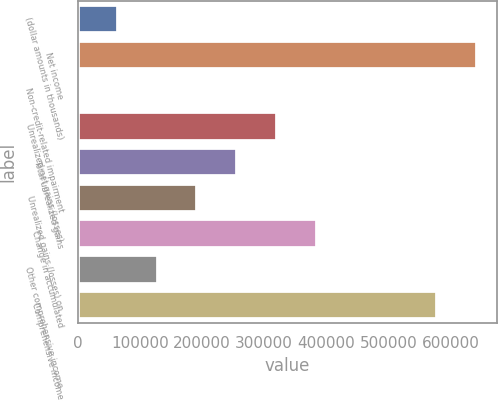Convert chart to OTSL. <chart><loc_0><loc_0><loc_500><loc_500><bar_chart><fcel>(dollar amounts in thousands)<fcel>Net income<fcel>Non-credit-related impairment<fcel>Unrealized net gains (losses)<fcel>Total unrealized gains<fcel>Unrealized gains (losses) on<fcel>Change in accumulated<fcel>Other comprehensive income<fcel>Comprehensive income<nl><fcel>64265.9<fcel>642203<fcel>153<fcel>320718<fcel>256605<fcel>192492<fcel>384830<fcel>128379<fcel>578090<nl></chart> 